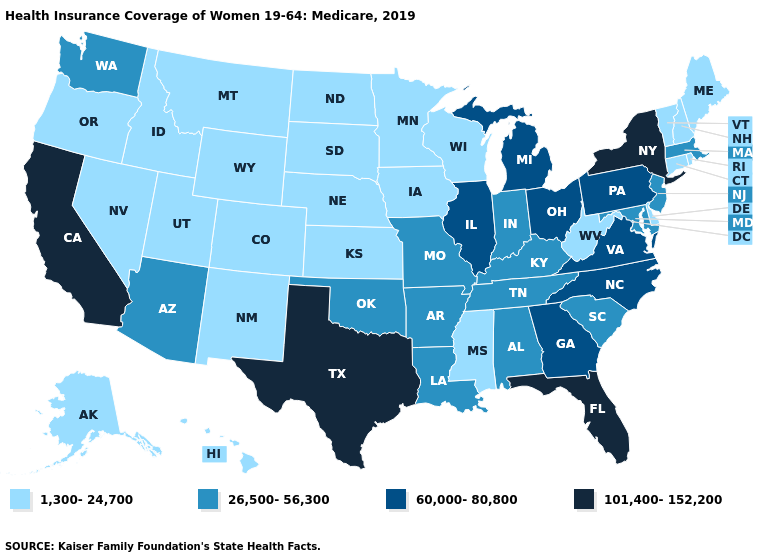Is the legend a continuous bar?
Quick response, please. No. Does Oklahoma have the same value as Virginia?
Concise answer only. No. Name the states that have a value in the range 26,500-56,300?
Short answer required. Alabama, Arizona, Arkansas, Indiana, Kentucky, Louisiana, Maryland, Massachusetts, Missouri, New Jersey, Oklahoma, South Carolina, Tennessee, Washington. What is the value of North Dakota?
Concise answer only. 1,300-24,700. What is the value of Nebraska?
Concise answer only. 1,300-24,700. Is the legend a continuous bar?
Quick response, please. No. Does Indiana have the lowest value in the MidWest?
Concise answer only. No. What is the value of Idaho?
Concise answer only. 1,300-24,700. Does Connecticut have the same value as Alaska?
Be succinct. Yes. What is the value of New Jersey?
Write a very short answer. 26,500-56,300. What is the value of New Mexico?
Concise answer only. 1,300-24,700. What is the lowest value in states that border Massachusetts?
Keep it brief. 1,300-24,700. Does Georgia have a lower value than Texas?
Short answer required. Yes. 